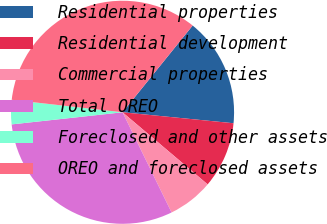<chart> <loc_0><loc_0><loc_500><loc_500><pie_chart><fcel>Residential properties<fcel>Residential development<fcel>Commercial properties<fcel>Total OREO<fcel>Foreclosed and other assets<fcel>OREO and foreclosed assets<nl><fcel>15.75%<fcel>9.62%<fcel>6.57%<fcel>30.51%<fcel>3.52%<fcel>34.03%<nl></chart> 